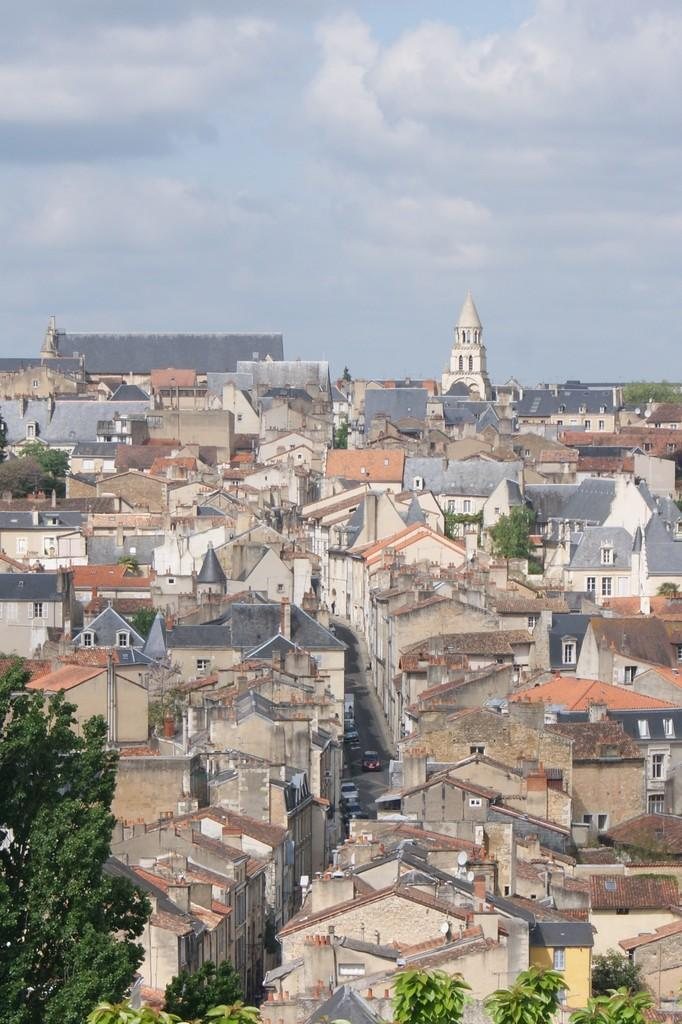What type of structures can be seen in the image? There are buildings in the image. What feature can be seen on the buildings? There are windows in the image. What else is present in the image besides buildings? There are vehicles and trees in the image. What is visible at the top of the image? The sky is visible at the top of the image. What can be seen in the sky? There are clouds in the sky. Where is the judge standing in the image? There is no judge present in the image. How many people are in the crowd in the image? There is no crowd present in the image. 